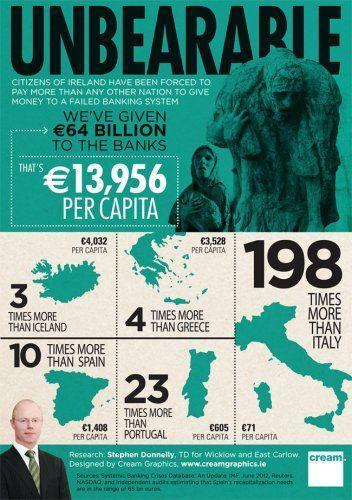How much more money is given in Iceland than Portugal per capita?
Answer the question with a short phrase. €3,427 What is the money given to the banks per capita in Iceland? €4,032 How much more money is given in Ireland than portugal per capita? €13,351 How much more money is given in Iceland than Greece per capita? €504 How much more money is given in Ireland than Italy per capita? €13,885 How much more money is given in Iceland than Italy per capita? €3,961 